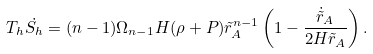<formula> <loc_0><loc_0><loc_500><loc_500>T _ { h } \dot { S _ { h } } = ( n - 1 ) \Omega _ { n - 1 } H ( \rho + P ) { \tilde { r } _ { A } } ^ { n - 1 } \left ( 1 - \frac { \dot { \tilde { r } } _ { A } } { 2 H \tilde { r } _ { A } } \right ) .</formula> 